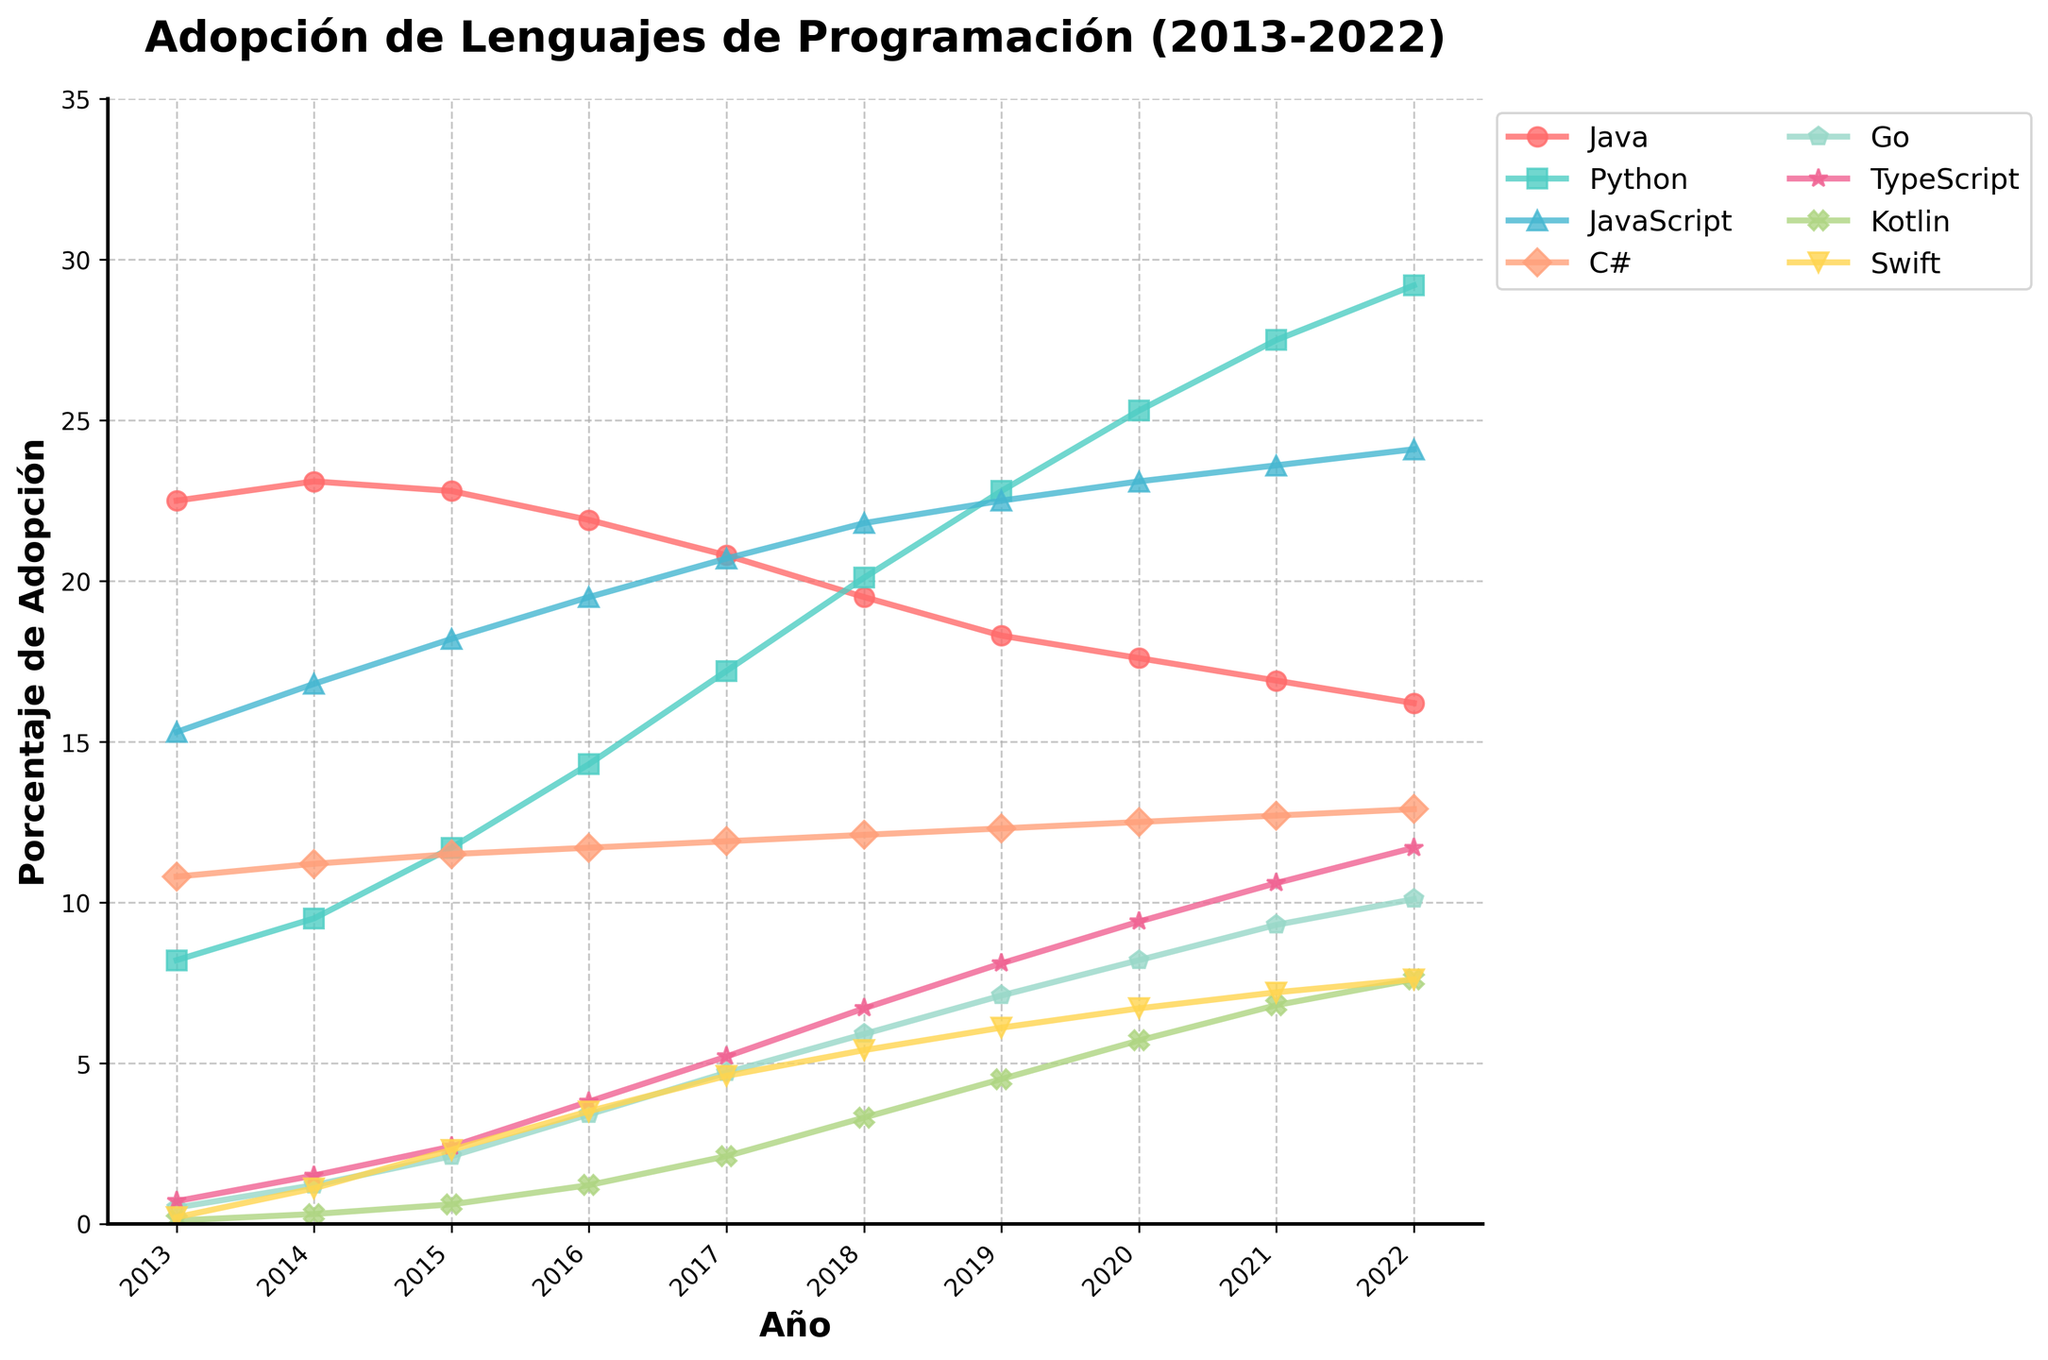Which programming language had the highest adoption in 2022? To determine the programming language with the highest adoption in 2022, look at the endpoints of each line in the plot. Python reaches the highest point at 29.2%.
Answer: Python Which language saw the greatest increase in adoption between 2013 and 2022? To identify which language saw the greatest increase, calculate the difference in percentages for each language from 2013 to 2022. Python grows from 8.2% to 29.2%, which is an increase of 21%.
Answer: Python In which year did JavaScript surpass Java in adoption? Find the year when the JavaScript line (turquoise) crosses above the Java line (red). This happens between 2015 and 2016.
Answer: 2016 How does the adoption of Kotlin in 2022 compare to its adoption in 2015? To compare, locate the adoption values for Kotlin in both years. In 2015, Kotlin was at 0.6%, and by 2022, it reached 7.6%.
Answer: It increased by 7% Which language had the least adoption in 2022? Look at the endpoints of all lines for 2022 and identify the lowest value. Swift has the lowest percentage at 7.6%.
Answer: Swift What is the combined adoption rate of Go and TypeScript in 2020? Find the adoption values for Go (8.2%) and TypeScript (9.4%) in 2020, then sum them: 8.2% + 9.4% = 17.6%.
Answer: 17.6% Has C# experienced a notable increase or decrease in adoption from 2013 to 2022? Compare C#'s adoption in 2013 (10.8%) to 2022 (12.9%) to determine if there is a significant change. C# increased by 2.1%.
Answer: Increase Which languages showed consistent growth every year from 2013 to 2022? Examine each line to see which ones consistently rise each year without any dips. Both Python and TypeScript show consistent annual growth.
Answer: Python and TypeScript How does Go’s adoption in 2016 compare to its adoption in 2019? Locate the values for Go in 2016 (3.4%) and 2019 (7.1%) to find the difference. Go increased by 3.7%.
Answer: Increased by 3.7% 